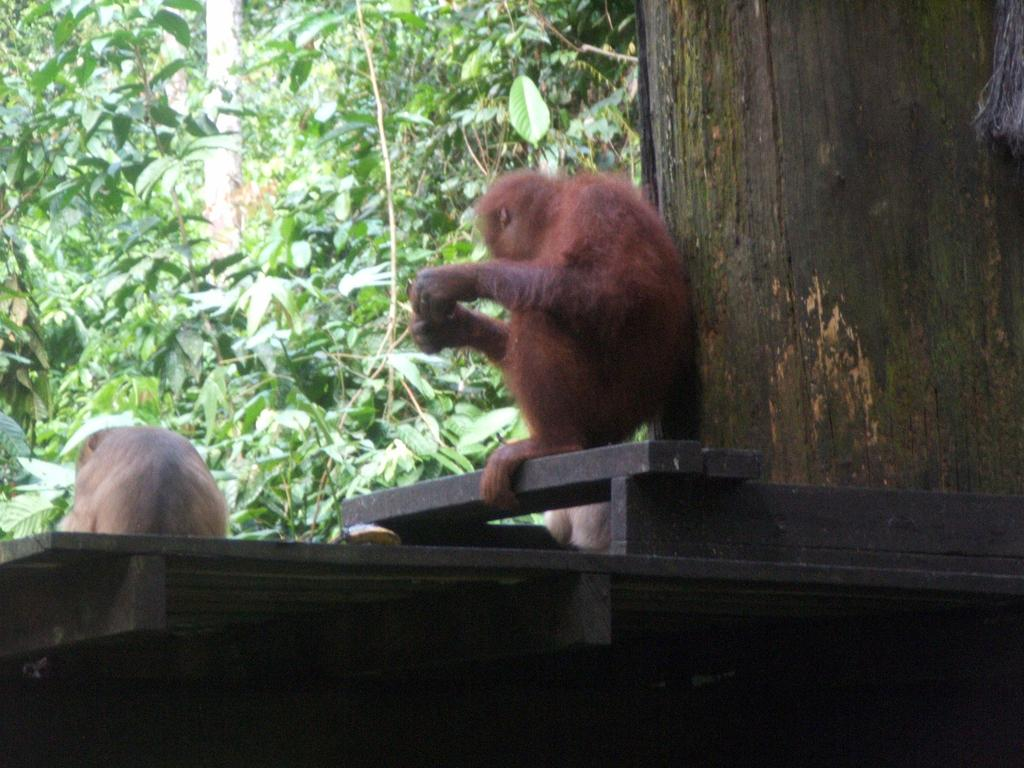What animals are on the platform in the image? There are monkeys on a platform in the image. What type of vegetation is visible in front of the platform? There are trees in front of the platform. Where is the trunk of a tree located in the image? The trunk of a tree is on the right side of the image. What type of paint is being used by the society in the image? There is no mention of paint or a society in the image; it features monkeys on a platform with trees in front. 